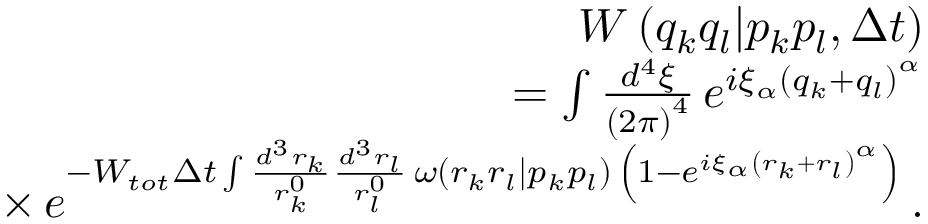<formula> <loc_0><loc_0><loc_500><loc_500>\begin{array} { r l r } & { W \left ( q _ { k } q _ { l } | p _ { k } p _ { l } , \Delta t \right ) } \\ & { = \int \frac { d ^ { 4 } \xi } { \left ( 2 \pi \right ) ^ { 4 } } \, e ^ { i \xi _ { \alpha } \left ( q _ { k } + q _ { l } \right ) ^ { \alpha } } } \\ & { \times \, e ^ { - W _ { t o t } \Delta t \int \frac { d ^ { 3 } r _ { k } } { r _ { k } ^ { 0 } } \frac { d ^ { 3 } r _ { l } } { r _ { l } ^ { 0 } } \, \omega \left ( r _ { k } r _ { l } | p _ { k } p _ { l } \right ) \, \left ( 1 - e ^ { i \xi _ { \alpha } \left ( r _ { k } + r _ { l } \right ) ^ { \alpha } } \right ) } \, . } \end{array}</formula> 